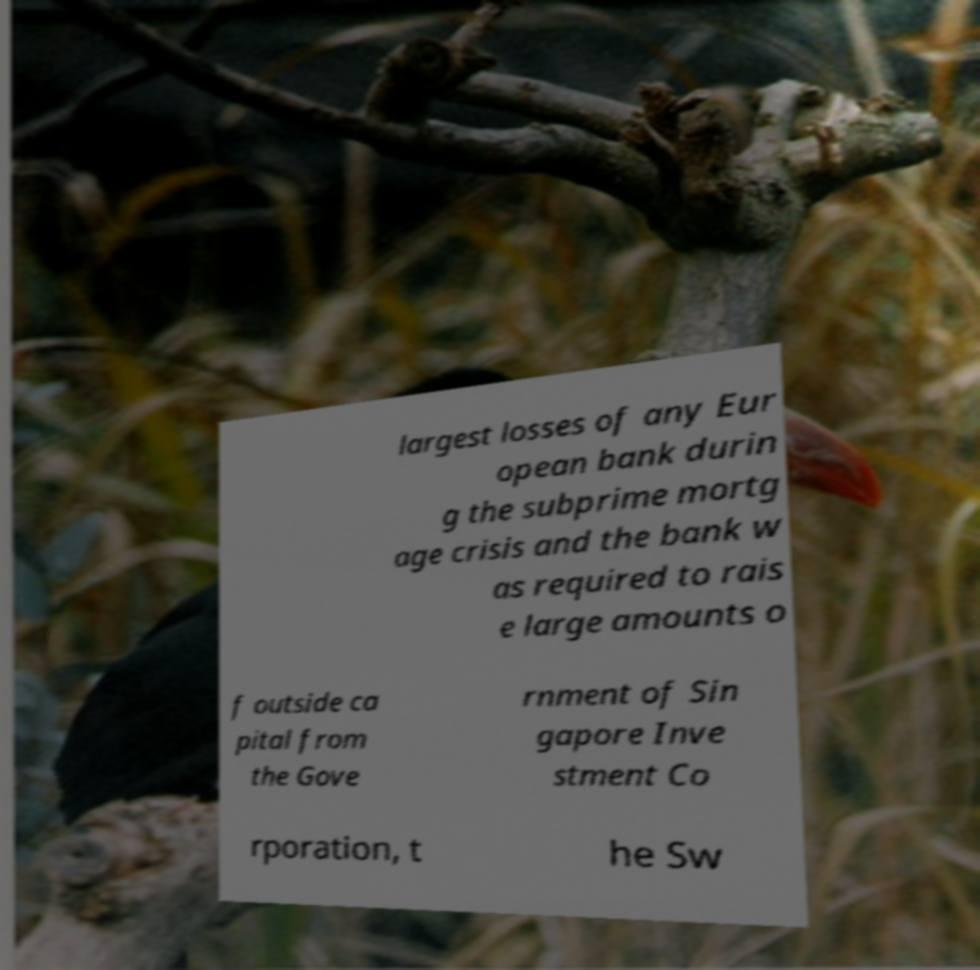What messages or text are displayed in this image? I need them in a readable, typed format. largest losses of any Eur opean bank durin g the subprime mortg age crisis and the bank w as required to rais e large amounts o f outside ca pital from the Gove rnment of Sin gapore Inve stment Co rporation, t he Sw 